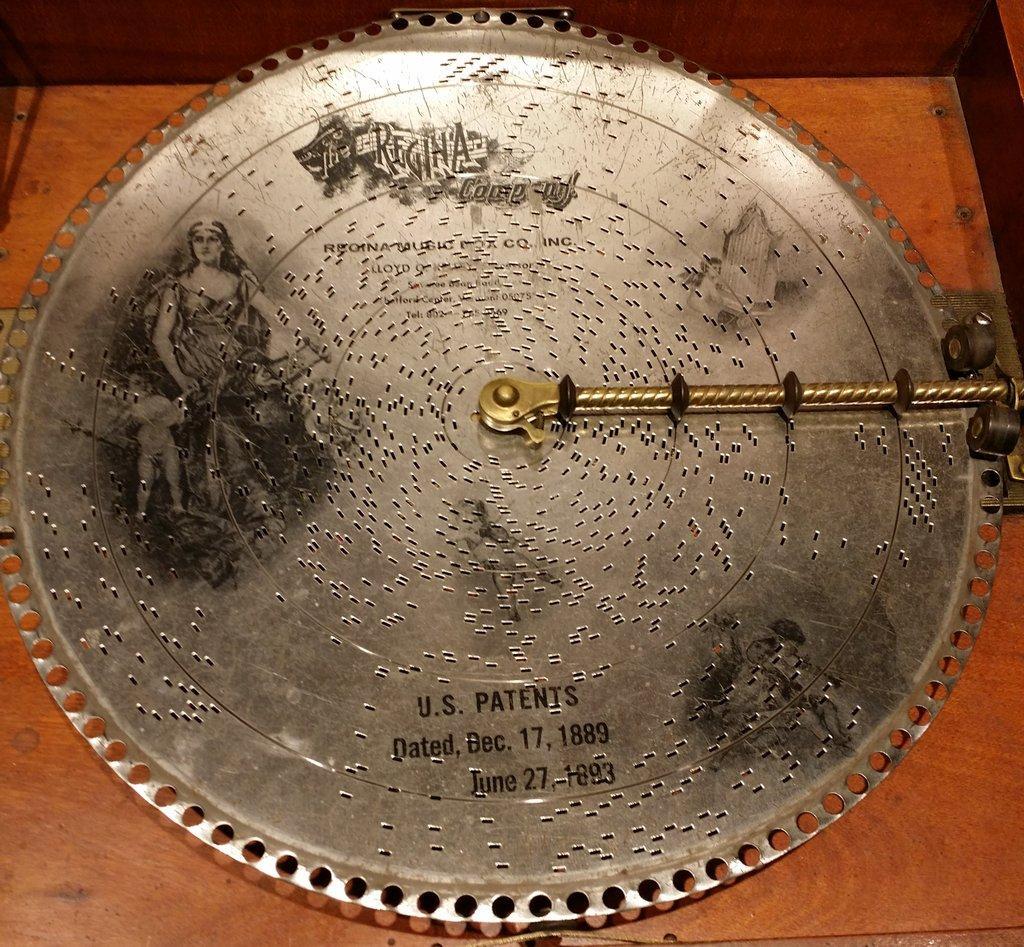Could you give a brief overview of what you see in this image? In the image we can see there is a silver plate kept on the table and there is a picture of a woman sitting on the table. There is matter written on the silver plate and the table is made up of wood. 